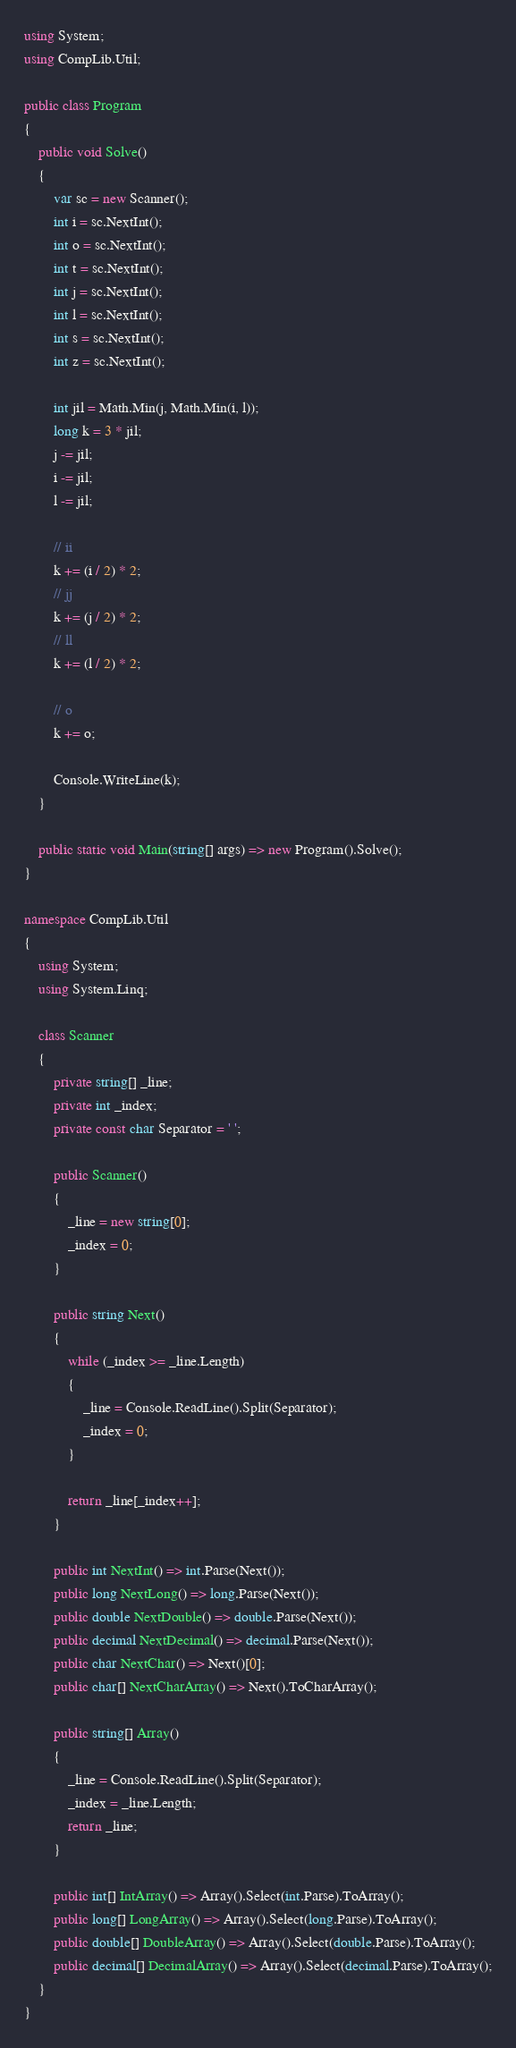<code> <loc_0><loc_0><loc_500><loc_500><_C#_>using System;
using CompLib.Util;

public class Program
{
    public void Solve()
    {
        var sc = new Scanner();
        int i = sc.NextInt();
        int o = sc.NextInt();
        int t = sc.NextInt();
        int j = sc.NextInt();
        int l = sc.NextInt();
        int s = sc.NextInt();
        int z = sc.NextInt();

        int jil = Math.Min(j, Math.Min(i, l));
        long k = 3 * jil;
        j -= jil;
        i -= jil;
        l -= jil;
        
        // ii
        k += (i / 2) * 2;
        // jj
        k += (j / 2) * 2;
        // ll
        k += (l / 2) * 2;
        
        // o
        k += o;

        Console.WriteLine(k);
    }

    public static void Main(string[] args) => new Program().Solve();
}

namespace CompLib.Util
{
    using System;
    using System.Linq;

    class Scanner
    {
        private string[] _line;
        private int _index;
        private const char Separator = ' ';

        public Scanner()
        {
            _line = new string[0];
            _index = 0;
        }

        public string Next()
        {
            while (_index >= _line.Length)
            {
                _line = Console.ReadLine().Split(Separator);
                _index = 0;
            }

            return _line[_index++];
        }

        public int NextInt() => int.Parse(Next());
        public long NextLong() => long.Parse(Next());
        public double NextDouble() => double.Parse(Next());
        public decimal NextDecimal() => decimal.Parse(Next());
        public char NextChar() => Next()[0];
        public char[] NextCharArray() => Next().ToCharArray();

        public string[] Array()
        {
            _line = Console.ReadLine().Split(Separator);
            _index = _line.Length;
            return _line;
        }

        public int[] IntArray() => Array().Select(int.Parse).ToArray();
        public long[] LongArray() => Array().Select(long.Parse).ToArray();
        public double[] DoubleArray() => Array().Select(double.Parse).ToArray();
        public decimal[] DecimalArray() => Array().Select(decimal.Parse).ToArray();
    }
}</code> 